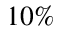<formula> <loc_0><loc_0><loc_500><loc_500>1 0 \%</formula> 